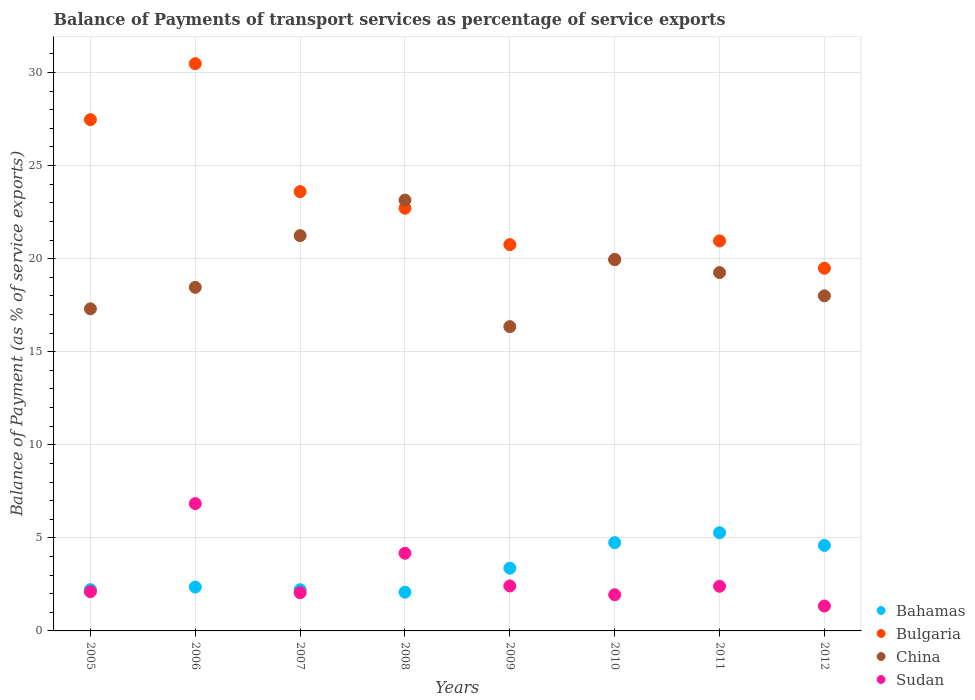Is the number of dotlines equal to the number of legend labels?
Make the answer very short. Yes. What is the balance of payments of transport services in China in 2012?
Give a very brief answer. 18. Across all years, what is the maximum balance of payments of transport services in China?
Your response must be concise. 23.14. Across all years, what is the minimum balance of payments of transport services in Sudan?
Ensure brevity in your answer.  1.34. In which year was the balance of payments of transport services in Sudan minimum?
Provide a short and direct response. 2012. What is the total balance of payments of transport services in Bulgaria in the graph?
Your response must be concise. 185.39. What is the difference between the balance of payments of transport services in Bulgaria in 2008 and that in 2011?
Provide a succinct answer. 1.75. What is the difference between the balance of payments of transport services in China in 2010 and the balance of payments of transport services in Bulgaria in 2007?
Provide a succinct answer. -3.65. What is the average balance of payments of transport services in Bahamas per year?
Keep it short and to the point. 3.36. In the year 2009, what is the difference between the balance of payments of transport services in Sudan and balance of payments of transport services in Bulgaria?
Offer a very short reply. -18.34. What is the ratio of the balance of payments of transport services in Bulgaria in 2006 to that in 2010?
Your answer should be very brief. 1.53. What is the difference between the highest and the second highest balance of payments of transport services in Bulgaria?
Offer a terse response. 3.01. What is the difference between the highest and the lowest balance of payments of transport services in Bulgaria?
Offer a terse response. 10.99. Is the balance of payments of transport services in Sudan strictly greater than the balance of payments of transport services in Bulgaria over the years?
Your answer should be compact. No. Does the graph contain grids?
Offer a very short reply. Yes. How many legend labels are there?
Your answer should be very brief. 4. What is the title of the graph?
Your response must be concise. Balance of Payments of transport services as percentage of service exports. Does "High income: OECD" appear as one of the legend labels in the graph?
Give a very brief answer. No. What is the label or title of the X-axis?
Offer a terse response. Years. What is the label or title of the Y-axis?
Give a very brief answer. Balance of Payment (as % of service exports). What is the Balance of Payment (as % of service exports) in Bahamas in 2005?
Ensure brevity in your answer.  2.22. What is the Balance of Payment (as % of service exports) of Bulgaria in 2005?
Give a very brief answer. 27.47. What is the Balance of Payment (as % of service exports) in China in 2005?
Give a very brief answer. 17.3. What is the Balance of Payment (as % of service exports) of Sudan in 2005?
Your response must be concise. 2.11. What is the Balance of Payment (as % of service exports) in Bahamas in 2006?
Ensure brevity in your answer.  2.36. What is the Balance of Payment (as % of service exports) in Bulgaria in 2006?
Make the answer very short. 30.47. What is the Balance of Payment (as % of service exports) of China in 2006?
Provide a short and direct response. 18.46. What is the Balance of Payment (as % of service exports) in Sudan in 2006?
Offer a terse response. 6.84. What is the Balance of Payment (as % of service exports) in Bahamas in 2007?
Your answer should be very brief. 2.21. What is the Balance of Payment (as % of service exports) of Bulgaria in 2007?
Make the answer very short. 23.6. What is the Balance of Payment (as % of service exports) in China in 2007?
Your answer should be very brief. 21.23. What is the Balance of Payment (as % of service exports) in Sudan in 2007?
Make the answer very short. 2.05. What is the Balance of Payment (as % of service exports) in Bahamas in 2008?
Ensure brevity in your answer.  2.08. What is the Balance of Payment (as % of service exports) in Bulgaria in 2008?
Ensure brevity in your answer.  22.71. What is the Balance of Payment (as % of service exports) of China in 2008?
Provide a succinct answer. 23.14. What is the Balance of Payment (as % of service exports) of Sudan in 2008?
Make the answer very short. 4.17. What is the Balance of Payment (as % of service exports) of Bahamas in 2009?
Ensure brevity in your answer.  3.37. What is the Balance of Payment (as % of service exports) of Bulgaria in 2009?
Provide a succinct answer. 20.75. What is the Balance of Payment (as % of service exports) of China in 2009?
Your answer should be compact. 16.35. What is the Balance of Payment (as % of service exports) of Sudan in 2009?
Make the answer very short. 2.41. What is the Balance of Payment (as % of service exports) in Bahamas in 2010?
Give a very brief answer. 4.74. What is the Balance of Payment (as % of service exports) in Bulgaria in 2010?
Provide a succinct answer. 19.95. What is the Balance of Payment (as % of service exports) in China in 2010?
Your response must be concise. 19.95. What is the Balance of Payment (as % of service exports) of Sudan in 2010?
Keep it short and to the point. 1.94. What is the Balance of Payment (as % of service exports) in Bahamas in 2011?
Offer a very short reply. 5.27. What is the Balance of Payment (as % of service exports) of Bulgaria in 2011?
Provide a succinct answer. 20.95. What is the Balance of Payment (as % of service exports) in China in 2011?
Your answer should be very brief. 19.25. What is the Balance of Payment (as % of service exports) of Sudan in 2011?
Ensure brevity in your answer.  2.4. What is the Balance of Payment (as % of service exports) of Bahamas in 2012?
Ensure brevity in your answer.  4.59. What is the Balance of Payment (as % of service exports) of Bulgaria in 2012?
Provide a short and direct response. 19.48. What is the Balance of Payment (as % of service exports) of China in 2012?
Provide a short and direct response. 18. What is the Balance of Payment (as % of service exports) in Sudan in 2012?
Your answer should be compact. 1.34. Across all years, what is the maximum Balance of Payment (as % of service exports) of Bahamas?
Provide a short and direct response. 5.27. Across all years, what is the maximum Balance of Payment (as % of service exports) of Bulgaria?
Offer a very short reply. 30.47. Across all years, what is the maximum Balance of Payment (as % of service exports) of China?
Keep it short and to the point. 23.14. Across all years, what is the maximum Balance of Payment (as % of service exports) of Sudan?
Offer a very short reply. 6.84. Across all years, what is the minimum Balance of Payment (as % of service exports) in Bahamas?
Keep it short and to the point. 2.08. Across all years, what is the minimum Balance of Payment (as % of service exports) of Bulgaria?
Give a very brief answer. 19.48. Across all years, what is the minimum Balance of Payment (as % of service exports) in China?
Provide a short and direct response. 16.35. Across all years, what is the minimum Balance of Payment (as % of service exports) in Sudan?
Make the answer very short. 1.34. What is the total Balance of Payment (as % of service exports) of Bahamas in the graph?
Your answer should be compact. 26.85. What is the total Balance of Payment (as % of service exports) of Bulgaria in the graph?
Provide a short and direct response. 185.39. What is the total Balance of Payment (as % of service exports) in China in the graph?
Provide a short and direct response. 153.69. What is the total Balance of Payment (as % of service exports) of Sudan in the graph?
Give a very brief answer. 23.27. What is the difference between the Balance of Payment (as % of service exports) of Bahamas in 2005 and that in 2006?
Provide a short and direct response. -0.14. What is the difference between the Balance of Payment (as % of service exports) of Bulgaria in 2005 and that in 2006?
Keep it short and to the point. -3.01. What is the difference between the Balance of Payment (as % of service exports) in China in 2005 and that in 2006?
Ensure brevity in your answer.  -1.15. What is the difference between the Balance of Payment (as % of service exports) in Sudan in 2005 and that in 2006?
Give a very brief answer. -4.73. What is the difference between the Balance of Payment (as % of service exports) of Bahamas in 2005 and that in 2007?
Offer a terse response. 0. What is the difference between the Balance of Payment (as % of service exports) in Bulgaria in 2005 and that in 2007?
Offer a terse response. 3.87. What is the difference between the Balance of Payment (as % of service exports) of China in 2005 and that in 2007?
Your response must be concise. -3.93. What is the difference between the Balance of Payment (as % of service exports) in Sudan in 2005 and that in 2007?
Provide a succinct answer. 0.05. What is the difference between the Balance of Payment (as % of service exports) in Bahamas in 2005 and that in 2008?
Your answer should be very brief. 0.14. What is the difference between the Balance of Payment (as % of service exports) in Bulgaria in 2005 and that in 2008?
Offer a terse response. 4.76. What is the difference between the Balance of Payment (as % of service exports) in China in 2005 and that in 2008?
Give a very brief answer. -5.84. What is the difference between the Balance of Payment (as % of service exports) of Sudan in 2005 and that in 2008?
Provide a succinct answer. -2.07. What is the difference between the Balance of Payment (as % of service exports) in Bahamas in 2005 and that in 2009?
Give a very brief answer. -1.15. What is the difference between the Balance of Payment (as % of service exports) in Bulgaria in 2005 and that in 2009?
Provide a succinct answer. 6.71. What is the difference between the Balance of Payment (as % of service exports) in China in 2005 and that in 2009?
Offer a terse response. 0.96. What is the difference between the Balance of Payment (as % of service exports) in Sudan in 2005 and that in 2009?
Keep it short and to the point. -0.31. What is the difference between the Balance of Payment (as % of service exports) in Bahamas in 2005 and that in 2010?
Offer a terse response. -2.53. What is the difference between the Balance of Payment (as % of service exports) of Bulgaria in 2005 and that in 2010?
Make the answer very short. 7.52. What is the difference between the Balance of Payment (as % of service exports) in China in 2005 and that in 2010?
Ensure brevity in your answer.  -2.65. What is the difference between the Balance of Payment (as % of service exports) in Sudan in 2005 and that in 2010?
Keep it short and to the point. 0.16. What is the difference between the Balance of Payment (as % of service exports) in Bahamas in 2005 and that in 2011?
Provide a short and direct response. -3.06. What is the difference between the Balance of Payment (as % of service exports) of Bulgaria in 2005 and that in 2011?
Your response must be concise. 6.51. What is the difference between the Balance of Payment (as % of service exports) in China in 2005 and that in 2011?
Offer a very short reply. -1.95. What is the difference between the Balance of Payment (as % of service exports) of Sudan in 2005 and that in 2011?
Ensure brevity in your answer.  -0.29. What is the difference between the Balance of Payment (as % of service exports) in Bahamas in 2005 and that in 2012?
Provide a short and direct response. -2.38. What is the difference between the Balance of Payment (as % of service exports) of Bulgaria in 2005 and that in 2012?
Your answer should be compact. 7.98. What is the difference between the Balance of Payment (as % of service exports) of China in 2005 and that in 2012?
Give a very brief answer. -0.7. What is the difference between the Balance of Payment (as % of service exports) in Sudan in 2005 and that in 2012?
Provide a short and direct response. 0.77. What is the difference between the Balance of Payment (as % of service exports) of Bahamas in 2006 and that in 2007?
Provide a short and direct response. 0.14. What is the difference between the Balance of Payment (as % of service exports) of Bulgaria in 2006 and that in 2007?
Ensure brevity in your answer.  6.87. What is the difference between the Balance of Payment (as % of service exports) of China in 2006 and that in 2007?
Your response must be concise. -2.78. What is the difference between the Balance of Payment (as % of service exports) in Sudan in 2006 and that in 2007?
Offer a very short reply. 4.79. What is the difference between the Balance of Payment (as % of service exports) of Bahamas in 2006 and that in 2008?
Give a very brief answer. 0.28. What is the difference between the Balance of Payment (as % of service exports) in Bulgaria in 2006 and that in 2008?
Ensure brevity in your answer.  7.77. What is the difference between the Balance of Payment (as % of service exports) in China in 2006 and that in 2008?
Your answer should be very brief. -4.69. What is the difference between the Balance of Payment (as % of service exports) of Sudan in 2006 and that in 2008?
Make the answer very short. 2.67. What is the difference between the Balance of Payment (as % of service exports) in Bahamas in 2006 and that in 2009?
Your answer should be compact. -1.01. What is the difference between the Balance of Payment (as % of service exports) in Bulgaria in 2006 and that in 2009?
Offer a terse response. 9.72. What is the difference between the Balance of Payment (as % of service exports) in China in 2006 and that in 2009?
Offer a very short reply. 2.11. What is the difference between the Balance of Payment (as % of service exports) in Sudan in 2006 and that in 2009?
Provide a short and direct response. 4.43. What is the difference between the Balance of Payment (as % of service exports) of Bahamas in 2006 and that in 2010?
Your response must be concise. -2.38. What is the difference between the Balance of Payment (as % of service exports) in Bulgaria in 2006 and that in 2010?
Your answer should be very brief. 10.52. What is the difference between the Balance of Payment (as % of service exports) of China in 2006 and that in 2010?
Offer a very short reply. -1.49. What is the difference between the Balance of Payment (as % of service exports) in Sudan in 2006 and that in 2010?
Your response must be concise. 4.9. What is the difference between the Balance of Payment (as % of service exports) of Bahamas in 2006 and that in 2011?
Provide a short and direct response. -2.92. What is the difference between the Balance of Payment (as % of service exports) of Bulgaria in 2006 and that in 2011?
Give a very brief answer. 9.52. What is the difference between the Balance of Payment (as % of service exports) in China in 2006 and that in 2011?
Your response must be concise. -0.79. What is the difference between the Balance of Payment (as % of service exports) in Sudan in 2006 and that in 2011?
Provide a succinct answer. 4.44. What is the difference between the Balance of Payment (as % of service exports) in Bahamas in 2006 and that in 2012?
Make the answer very short. -2.24. What is the difference between the Balance of Payment (as % of service exports) in Bulgaria in 2006 and that in 2012?
Offer a terse response. 10.99. What is the difference between the Balance of Payment (as % of service exports) in China in 2006 and that in 2012?
Give a very brief answer. 0.46. What is the difference between the Balance of Payment (as % of service exports) of Sudan in 2006 and that in 2012?
Your response must be concise. 5.5. What is the difference between the Balance of Payment (as % of service exports) in Bahamas in 2007 and that in 2008?
Your answer should be compact. 0.13. What is the difference between the Balance of Payment (as % of service exports) of Bulgaria in 2007 and that in 2008?
Your answer should be very brief. 0.89. What is the difference between the Balance of Payment (as % of service exports) in China in 2007 and that in 2008?
Make the answer very short. -1.91. What is the difference between the Balance of Payment (as % of service exports) of Sudan in 2007 and that in 2008?
Your response must be concise. -2.12. What is the difference between the Balance of Payment (as % of service exports) in Bahamas in 2007 and that in 2009?
Offer a terse response. -1.16. What is the difference between the Balance of Payment (as % of service exports) in Bulgaria in 2007 and that in 2009?
Your answer should be very brief. 2.85. What is the difference between the Balance of Payment (as % of service exports) in China in 2007 and that in 2009?
Offer a terse response. 4.89. What is the difference between the Balance of Payment (as % of service exports) in Sudan in 2007 and that in 2009?
Provide a short and direct response. -0.36. What is the difference between the Balance of Payment (as % of service exports) of Bahamas in 2007 and that in 2010?
Provide a succinct answer. -2.53. What is the difference between the Balance of Payment (as % of service exports) of Bulgaria in 2007 and that in 2010?
Make the answer very short. 3.65. What is the difference between the Balance of Payment (as % of service exports) in China in 2007 and that in 2010?
Your answer should be very brief. 1.29. What is the difference between the Balance of Payment (as % of service exports) of Sudan in 2007 and that in 2010?
Offer a very short reply. 0.11. What is the difference between the Balance of Payment (as % of service exports) of Bahamas in 2007 and that in 2011?
Provide a short and direct response. -3.06. What is the difference between the Balance of Payment (as % of service exports) of Bulgaria in 2007 and that in 2011?
Offer a terse response. 2.65. What is the difference between the Balance of Payment (as % of service exports) in China in 2007 and that in 2011?
Offer a terse response. 1.98. What is the difference between the Balance of Payment (as % of service exports) in Sudan in 2007 and that in 2011?
Your response must be concise. -0.35. What is the difference between the Balance of Payment (as % of service exports) of Bahamas in 2007 and that in 2012?
Provide a short and direct response. -2.38. What is the difference between the Balance of Payment (as % of service exports) in Bulgaria in 2007 and that in 2012?
Provide a succinct answer. 4.12. What is the difference between the Balance of Payment (as % of service exports) in China in 2007 and that in 2012?
Offer a terse response. 3.23. What is the difference between the Balance of Payment (as % of service exports) of Sudan in 2007 and that in 2012?
Provide a succinct answer. 0.71. What is the difference between the Balance of Payment (as % of service exports) of Bahamas in 2008 and that in 2009?
Your answer should be very brief. -1.29. What is the difference between the Balance of Payment (as % of service exports) in Bulgaria in 2008 and that in 2009?
Make the answer very short. 1.96. What is the difference between the Balance of Payment (as % of service exports) of China in 2008 and that in 2009?
Make the answer very short. 6.8. What is the difference between the Balance of Payment (as % of service exports) of Sudan in 2008 and that in 2009?
Ensure brevity in your answer.  1.76. What is the difference between the Balance of Payment (as % of service exports) of Bahamas in 2008 and that in 2010?
Your response must be concise. -2.66. What is the difference between the Balance of Payment (as % of service exports) of Bulgaria in 2008 and that in 2010?
Make the answer very short. 2.76. What is the difference between the Balance of Payment (as % of service exports) in China in 2008 and that in 2010?
Your answer should be compact. 3.2. What is the difference between the Balance of Payment (as % of service exports) in Sudan in 2008 and that in 2010?
Your answer should be compact. 2.23. What is the difference between the Balance of Payment (as % of service exports) of Bahamas in 2008 and that in 2011?
Make the answer very short. -3.19. What is the difference between the Balance of Payment (as % of service exports) of Bulgaria in 2008 and that in 2011?
Ensure brevity in your answer.  1.75. What is the difference between the Balance of Payment (as % of service exports) of China in 2008 and that in 2011?
Make the answer very short. 3.89. What is the difference between the Balance of Payment (as % of service exports) of Sudan in 2008 and that in 2011?
Your response must be concise. 1.77. What is the difference between the Balance of Payment (as % of service exports) of Bahamas in 2008 and that in 2012?
Ensure brevity in your answer.  -2.51. What is the difference between the Balance of Payment (as % of service exports) in Bulgaria in 2008 and that in 2012?
Your response must be concise. 3.22. What is the difference between the Balance of Payment (as % of service exports) in China in 2008 and that in 2012?
Your answer should be compact. 5.14. What is the difference between the Balance of Payment (as % of service exports) in Sudan in 2008 and that in 2012?
Offer a very short reply. 2.83. What is the difference between the Balance of Payment (as % of service exports) in Bahamas in 2009 and that in 2010?
Offer a terse response. -1.37. What is the difference between the Balance of Payment (as % of service exports) of Bulgaria in 2009 and that in 2010?
Provide a short and direct response. 0.8. What is the difference between the Balance of Payment (as % of service exports) of China in 2009 and that in 2010?
Provide a succinct answer. -3.6. What is the difference between the Balance of Payment (as % of service exports) of Sudan in 2009 and that in 2010?
Your answer should be very brief. 0.47. What is the difference between the Balance of Payment (as % of service exports) in Bahamas in 2009 and that in 2011?
Make the answer very short. -1.9. What is the difference between the Balance of Payment (as % of service exports) of Bulgaria in 2009 and that in 2011?
Your answer should be compact. -0.2. What is the difference between the Balance of Payment (as % of service exports) in China in 2009 and that in 2011?
Your answer should be very brief. -2.91. What is the difference between the Balance of Payment (as % of service exports) of Sudan in 2009 and that in 2011?
Give a very brief answer. 0.02. What is the difference between the Balance of Payment (as % of service exports) of Bahamas in 2009 and that in 2012?
Your answer should be very brief. -1.22. What is the difference between the Balance of Payment (as % of service exports) in Bulgaria in 2009 and that in 2012?
Your answer should be compact. 1.27. What is the difference between the Balance of Payment (as % of service exports) in China in 2009 and that in 2012?
Ensure brevity in your answer.  -1.66. What is the difference between the Balance of Payment (as % of service exports) of Sudan in 2009 and that in 2012?
Offer a terse response. 1.08. What is the difference between the Balance of Payment (as % of service exports) of Bahamas in 2010 and that in 2011?
Offer a very short reply. -0.53. What is the difference between the Balance of Payment (as % of service exports) in Bulgaria in 2010 and that in 2011?
Offer a very short reply. -1. What is the difference between the Balance of Payment (as % of service exports) in China in 2010 and that in 2011?
Your answer should be compact. 0.7. What is the difference between the Balance of Payment (as % of service exports) of Sudan in 2010 and that in 2011?
Ensure brevity in your answer.  -0.46. What is the difference between the Balance of Payment (as % of service exports) of Bahamas in 2010 and that in 2012?
Provide a succinct answer. 0.15. What is the difference between the Balance of Payment (as % of service exports) of Bulgaria in 2010 and that in 2012?
Offer a terse response. 0.47. What is the difference between the Balance of Payment (as % of service exports) of China in 2010 and that in 2012?
Provide a succinct answer. 1.95. What is the difference between the Balance of Payment (as % of service exports) of Sudan in 2010 and that in 2012?
Make the answer very short. 0.61. What is the difference between the Balance of Payment (as % of service exports) in Bahamas in 2011 and that in 2012?
Offer a terse response. 0.68. What is the difference between the Balance of Payment (as % of service exports) of Bulgaria in 2011 and that in 2012?
Ensure brevity in your answer.  1.47. What is the difference between the Balance of Payment (as % of service exports) in China in 2011 and that in 2012?
Provide a short and direct response. 1.25. What is the difference between the Balance of Payment (as % of service exports) of Sudan in 2011 and that in 2012?
Provide a succinct answer. 1.06. What is the difference between the Balance of Payment (as % of service exports) in Bahamas in 2005 and the Balance of Payment (as % of service exports) in Bulgaria in 2006?
Your answer should be compact. -28.26. What is the difference between the Balance of Payment (as % of service exports) in Bahamas in 2005 and the Balance of Payment (as % of service exports) in China in 2006?
Your answer should be compact. -16.24. What is the difference between the Balance of Payment (as % of service exports) of Bahamas in 2005 and the Balance of Payment (as % of service exports) of Sudan in 2006?
Offer a terse response. -4.62. What is the difference between the Balance of Payment (as % of service exports) of Bulgaria in 2005 and the Balance of Payment (as % of service exports) of China in 2006?
Your response must be concise. 9.01. What is the difference between the Balance of Payment (as % of service exports) in Bulgaria in 2005 and the Balance of Payment (as % of service exports) in Sudan in 2006?
Keep it short and to the point. 20.63. What is the difference between the Balance of Payment (as % of service exports) in China in 2005 and the Balance of Payment (as % of service exports) in Sudan in 2006?
Provide a succinct answer. 10.46. What is the difference between the Balance of Payment (as % of service exports) of Bahamas in 2005 and the Balance of Payment (as % of service exports) of Bulgaria in 2007?
Your response must be concise. -21.38. What is the difference between the Balance of Payment (as % of service exports) of Bahamas in 2005 and the Balance of Payment (as % of service exports) of China in 2007?
Your answer should be compact. -19.02. What is the difference between the Balance of Payment (as % of service exports) in Bahamas in 2005 and the Balance of Payment (as % of service exports) in Sudan in 2007?
Your answer should be compact. 0.16. What is the difference between the Balance of Payment (as % of service exports) of Bulgaria in 2005 and the Balance of Payment (as % of service exports) of China in 2007?
Keep it short and to the point. 6.23. What is the difference between the Balance of Payment (as % of service exports) of Bulgaria in 2005 and the Balance of Payment (as % of service exports) of Sudan in 2007?
Provide a short and direct response. 25.41. What is the difference between the Balance of Payment (as % of service exports) in China in 2005 and the Balance of Payment (as % of service exports) in Sudan in 2007?
Ensure brevity in your answer.  15.25. What is the difference between the Balance of Payment (as % of service exports) of Bahamas in 2005 and the Balance of Payment (as % of service exports) of Bulgaria in 2008?
Offer a very short reply. -20.49. What is the difference between the Balance of Payment (as % of service exports) of Bahamas in 2005 and the Balance of Payment (as % of service exports) of China in 2008?
Offer a very short reply. -20.93. What is the difference between the Balance of Payment (as % of service exports) in Bahamas in 2005 and the Balance of Payment (as % of service exports) in Sudan in 2008?
Offer a terse response. -1.96. What is the difference between the Balance of Payment (as % of service exports) of Bulgaria in 2005 and the Balance of Payment (as % of service exports) of China in 2008?
Provide a succinct answer. 4.32. What is the difference between the Balance of Payment (as % of service exports) in Bulgaria in 2005 and the Balance of Payment (as % of service exports) in Sudan in 2008?
Make the answer very short. 23.29. What is the difference between the Balance of Payment (as % of service exports) of China in 2005 and the Balance of Payment (as % of service exports) of Sudan in 2008?
Keep it short and to the point. 13.13. What is the difference between the Balance of Payment (as % of service exports) of Bahamas in 2005 and the Balance of Payment (as % of service exports) of Bulgaria in 2009?
Your answer should be compact. -18.54. What is the difference between the Balance of Payment (as % of service exports) in Bahamas in 2005 and the Balance of Payment (as % of service exports) in China in 2009?
Make the answer very short. -14.13. What is the difference between the Balance of Payment (as % of service exports) of Bahamas in 2005 and the Balance of Payment (as % of service exports) of Sudan in 2009?
Give a very brief answer. -0.2. What is the difference between the Balance of Payment (as % of service exports) of Bulgaria in 2005 and the Balance of Payment (as % of service exports) of China in 2009?
Keep it short and to the point. 11.12. What is the difference between the Balance of Payment (as % of service exports) of Bulgaria in 2005 and the Balance of Payment (as % of service exports) of Sudan in 2009?
Your response must be concise. 25.05. What is the difference between the Balance of Payment (as % of service exports) of China in 2005 and the Balance of Payment (as % of service exports) of Sudan in 2009?
Offer a terse response. 14.89. What is the difference between the Balance of Payment (as % of service exports) in Bahamas in 2005 and the Balance of Payment (as % of service exports) in Bulgaria in 2010?
Offer a terse response. -17.74. What is the difference between the Balance of Payment (as % of service exports) of Bahamas in 2005 and the Balance of Payment (as % of service exports) of China in 2010?
Keep it short and to the point. -17.73. What is the difference between the Balance of Payment (as % of service exports) of Bahamas in 2005 and the Balance of Payment (as % of service exports) of Sudan in 2010?
Make the answer very short. 0.27. What is the difference between the Balance of Payment (as % of service exports) of Bulgaria in 2005 and the Balance of Payment (as % of service exports) of China in 2010?
Offer a very short reply. 7.52. What is the difference between the Balance of Payment (as % of service exports) in Bulgaria in 2005 and the Balance of Payment (as % of service exports) in Sudan in 2010?
Ensure brevity in your answer.  25.52. What is the difference between the Balance of Payment (as % of service exports) of China in 2005 and the Balance of Payment (as % of service exports) of Sudan in 2010?
Your answer should be very brief. 15.36. What is the difference between the Balance of Payment (as % of service exports) of Bahamas in 2005 and the Balance of Payment (as % of service exports) of Bulgaria in 2011?
Your response must be concise. -18.74. What is the difference between the Balance of Payment (as % of service exports) in Bahamas in 2005 and the Balance of Payment (as % of service exports) in China in 2011?
Give a very brief answer. -17.04. What is the difference between the Balance of Payment (as % of service exports) of Bahamas in 2005 and the Balance of Payment (as % of service exports) of Sudan in 2011?
Give a very brief answer. -0.18. What is the difference between the Balance of Payment (as % of service exports) in Bulgaria in 2005 and the Balance of Payment (as % of service exports) in China in 2011?
Give a very brief answer. 8.21. What is the difference between the Balance of Payment (as % of service exports) of Bulgaria in 2005 and the Balance of Payment (as % of service exports) of Sudan in 2011?
Your response must be concise. 25.07. What is the difference between the Balance of Payment (as % of service exports) of China in 2005 and the Balance of Payment (as % of service exports) of Sudan in 2011?
Ensure brevity in your answer.  14.9. What is the difference between the Balance of Payment (as % of service exports) of Bahamas in 2005 and the Balance of Payment (as % of service exports) of Bulgaria in 2012?
Keep it short and to the point. -17.27. What is the difference between the Balance of Payment (as % of service exports) of Bahamas in 2005 and the Balance of Payment (as % of service exports) of China in 2012?
Your response must be concise. -15.79. What is the difference between the Balance of Payment (as % of service exports) in Bahamas in 2005 and the Balance of Payment (as % of service exports) in Sudan in 2012?
Your answer should be very brief. 0.88. What is the difference between the Balance of Payment (as % of service exports) of Bulgaria in 2005 and the Balance of Payment (as % of service exports) of China in 2012?
Your answer should be very brief. 9.46. What is the difference between the Balance of Payment (as % of service exports) in Bulgaria in 2005 and the Balance of Payment (as % of service exports) in Sudan in 2012?
Make the answer very short. 26.13. What is the difference between the Balance of Payment (as % of service exports) of China in 2005 and the Balance of Payment (as % of service exports) of Sudan in 2012?
Offer a terse response. 15.97. What is the difference between the Balance of Payment (as % of service exports) in Bahamas in 2006 and the Balance of Payment (as % of service exports) in Bulgaria in 2007?
Your answer should be compact. -21.24. What is the difference between the Balance of Payment (as % of service exports) in Bahamas in 2006 and the Balance of Payment (as % of service exports) in China in 2007?
Give a very brief answer. -18.88. What is the difference between the Balance of Payment (as % of service exports) in Bahamas in 2006 and the Balance of Payment (as % of service exports) in Sudan in 2007?
Give a very brief answer. 0.3. What is the difference between the Balance of Payment (as % of service exports) of Bulgaria in 2006 and the Balance of Payment (as % of service exports) of China in 2007?
Your answer should be very brief. 9.24. What is the difference between the Balance of Payment (as % of service exports) of Bulgaria in 2006 and the Balance of Payment (as % of service exports) of Sudan in 2007?
Ensure brevity in your answer.  28.42. What is the difference between the Balance of Payment (as % of service exports) of China in 2006 and the Balance of Payment (as % of service exports) of Sudan in 2007?
Provide a succinct answer. 16.41. What is the difference between the Balance of Payment (as % of service exports) in Bahamas in 2006 and the Balance of Payment (as % of service exports) in Bulgaria in 2008?
Ensure brevity in your answer.  -20.35. What is the difference between the Balance of Payment (as % of service exports) of Bahamas in 2006 and the Balance of Payment (as % of service exports) of China in 2008?
Offer a terse response. -20.79. What is the difference between the Balance of Payment (as % of service exports) of Bahamas in 2006 and the Balance of Payment (as % of service exports) of Sudan in 2008?
Your answer should be compact. -1.82. What is the difference between the Balance of Payment (as % of service exports) in Bulgaria in 2006 and the Balance of Payment (as % of service exports) in China in 2008?
Your answer should be compact. 7.33. What is the difference between the Balance of Payment (as % of service exports) in Bulgaria in 2006 and the Balance of Payment (as % of service exports) in Sudan in 2008?
Provide a short and direct response. 26.3. What is the difference between the Balance of Payment (as % of service exports) in China in 2006 and the Balance of Payment (as % of service exports) in Sudan in 2008?
Ensure brevity in your answer.  14.29. What is the difference between the Balance of Payment (as % of service exports) in Bahamas in 2006 and the Balance of Payment (as % of service exports) in Bulgaria in 2009?
Make the answer very short. -18.4. What is the difference between the Balance of Payment (as % of service exports) in Bahamas in 2006 and the Balance of Payment (as % of service exports) in China in 2009?
Offer a very short reply. -13.99. What is the difference between the Balance of Payment (as % of service exports) of Bahamas in 2006 and the Balance of Payment (as % of service exports) of Sudan in 2009?
Ensure brevity in your answer.  -0.06. What is the difference between the Balance of Payment (as % of service exports) of Bulgaria in 2006 and the Balance of Payment (as % of service exports) of China in 2009?
Provide a succinct answer. 14.13. What is the difference between the Balance of Payment (as % of service exports) of Bulgaria in 2006 and the Balance of Payment (as % of service exports) of Sudan in 2009?
Provide a short and direct response. 28.06. What is the difference between the Balance of Payment (as % of service exports) of China in 2006 and the Balance of Payment (as % of service exports) of Sudan in 2009?
Make the answer very short. 16.04. What is the difference between the Balance of Payment (as % of service exports) of Bahamas in 2006 and the Balance of Payment (as % of service exports) of Bulgaria in 2010?
Your response must be concise. -17.59. What is the difference between the Balance of Payment (as % of service exports) of Bahamas in 2006 and the Balance of Payment (as % of service exports) of China in 2010?
Give a very brief answer. -17.59. What is the difference between the Balance of Payment (as % of service exports) of Bahamas in 2006 and the Balance of Payment (as % of service exports) of Sudan in 2010?
Provide a succinct answer. 0.41. What is the difference between the Balance of Payment (as % of service exports) of Bulgaria in 2006 and the Balance of Payment (as % of service exports) of China in 2010?
Give a very brief answer. 10.52. What is the difference between the Balance of Payment (as % of service exports) of Bulgaria in 2006 and the Balance of Payment (as % of service exports) of Sudan in 2010?
Provide a short and direct response. 28.53. What is the difference between the Balance of Payment (as % of service exports) of China in 2006 and the Balance of Payment (as % of service exports) of Sudan in 2010?
Offer a terse response. 16.52. What is the difference between the Balance of Payment (as % of service exports) of Bahamas in 2006 and the Balance of Payment (as % of service exports) of Bulgaria in 2011?
Give a very brief answer. -18.6. What is the difference between the Balance of Payment (as % of service exports) of Bahamas in 2006 and the Balance of Payment (as % of service exports) of China in 2011?
Your response must be concise. -16.89. What is the difference between the Balance of Payment (as % of service exports) in Bahamas in 2006 and the Balance of Payment (as % of service exports) in Sudan in 2011?
Your response must be concise. -0.04. What is the difference between the Balance of Payment (as % of service exports) of Bulgaria in 2006 and the Balance of Payment (as % of service exports) of China in 2011?
Provide a short and direct response. 11.22. What is the difference between the Balance of Payment (as % of service exports) in Bulgaria in 2006 and the Balance of Payment (as % of service exports) in Sudan in 2011?
Offer a very short reply. 28.07. What is the difference between the Balance of Payment (as % of service exports) in China in 2006 and the Balance of Payment (as % of service exports) in Sudan in 2011?
Provide a succinct answer. 16.06. What is the difference between the Balance of Payment (as % of service exports) of Bahamas in 2006 and the Balance of Payment (as % of service exports) of Bulgaria in 2012?
Give a very brief answer. -17.13. What is the difference between the Balance of Payment (as % of service exports) of Bahamas in 2006 and the Balance of Payment (as % of service exports) of China in 2012?
Keep it short and to the point. -15.65. What is the difference between the Balance of Payment (as % of service exports) of Bahamas in 2006 and the Balance of Payment (as % of service exports) of Sudan in 2012?
Provide a succinct answer. 1.02. What is the difference between the Balance of Payment (as % of service exports) of Bulgaria in 2006 and the Balance of Payment (as % of service exports) of China in 2012?
Offer a terse response. 12.47. What is the difference between the Balance of Payment (as % of service exports) in Bulgaria in 2006 and the Balance of Payment (as % of service exports) in Sudan in 2012?
Ensure brevity in your answer.  29.13. What is the difference between the Balance of Payment (as % of service exports) in China in 2006 and the Balance of Payment (as % of service exports) in Sudan in 2012?
Your answer should be very brief. 17.12. What is the difference between the Balance of Payment (as % of service exports) in Bahamas in 2007 and the Balance of Payment (as % of service exports) in Bulgaria in 2008?
Make the answer very short. -20.49. What is the difference between the Balance of Payment (as % of service exports) of Bahamas in 2007 and the Balance of Payment (as % of service exports) of China in 2008?
Your answer should be compact. -20.93. What is the difference between the Balance of Payment (as % of service exports) in Bahamas in 2007 and the Balance of Payment (as % of service exports) in Sudan in 2008?
Offer a very short reply. -1.96. What is the difference between the Balance of Payment (as % of service exports) in Bulgaria in 2007 and the Balance of Payment (as % of service exports) in China in 2008?
Your answer should be compact. 0.45. What is the difference between the Balance of Payment (as % of service exports) of Bulgaria in 2007 and the Balance of Payment (as % of service exports) of Sudan in 2008?
Ensure brevity in your answer.  19.43. What is the difference between the Balance of Payment (as % of service exports) in China in 2007 and the Balance of Payment (as % of service exports) in Sudan in 2008?
Your answer should be very brief. 17.06. What is the difference between the Balance of Payment (as % of service exports) of Bahamas in 2007 and the Balance of Payment (as % of service exports) of Bulgaria in 2009?
Your answer should be compact. -18.54. What is the difference between the Balance of Payment (as % of service exports) in Bahamas in 2007 and the Balance of Payment (as % of service exports) in China in 2009?
Give a very brief answer. -14.13. What is the difference between the Balance of Payment (as % of service exports) of Bahamas in 2007 and the Balance of Payment (as % of service exports) of Sudan in 2009?
Provide a short and direct response. -0.2. What is the difference between the Balance of Payment (as % of service exports) in Bulgaria in 2007 and the Balance of Payment (as % of service exports) in China in 2009?
Provide a succinct answer. 7.25. What is the difference between the Balance of Payment (as % of service exports) of Bulgaria in 2007 and the Balance of Payment (as % of service exports) of Sudan in 2009?
Your response must be concise. 21.18. What is the difference between the Balance of Payment (as % of service exports) of China in 2007 and the Balance of Payment (as % of service exports) of Sudan in 2009?
Offer a very short reply. 18.82. What is the difference between the Balance of Payment (as % of service exports) of Bahamas in 2007 and the Balance of Payment (as % of service exports) of Bulgaria in 2010?
Make the answer very short. -17.74. What is the difference between the Balance of Payment (as % of service exports) of Bahamas in 2007 and the Balance of Payment (as % of service exports) of China in 2010?
Keep it short and to the point. -17.74. What is the difference between the Balance of Payment (as % of service exports) of Bahamas in 2007 and the Balance of Payment (as % of service exports) of Sudan in 2010?
Give a very brief answer. 0.27. What is the difference between the Balance of Payment (as % of service exports) in Bulgaria in 2007 and the Balance of Payment (as % of service exports) in China in 2010?
Offer a very short reply. 3.65. What is the difference between the Balance of Payment (as % of service exports) of Bulgaria in 2007 and the Balance of Payment (as % of service exports) of Sudan in 2010?
Your answer should be compact. 21.66. What is the difference between the Balance of Payment (as % of service exports) of China in 2007 and the Balance of Payment (as % of service exports) of Sudan in 2010?
Your response must be concise. 19.29. What is the difference between the Balance of Payment (as % of service exports) in Bahamas in 2007 and the Balance of Payment (as % of service exports) in Bulgaria in 2011?
Provide a succinct answer. -18.74. What is the difference between the Balance of Payment (as % of service exports) of Bahamas in 2007 and the Balance of Payment (as % of service exports) of China in 2011?
Ensure brevity in your answer.  -17.04. What is the difference between the Balance of Payment (as % of service exports) of Bahamas in 2007 and the Balance of Payment (as % of service exports) of Sudan in 2011?
Your response must be concise. -0.19. What is the difference between the Balance of Payment (as % of service exports) in Bulgaria in 2007 and the Balance of Payment (as % of service exports) in China in 2011?
Ensure brevity in your answer.  4.35. What is the difference between the Balance of Payment (as % of service exports) of Bulgaria in 2007 and the Balance of Payment (as % of service exports) of Sudan in 2011?
Offer a very short reply. 21.2. What is the difference between the Balance of Payment (as % of service exports) in China in 2007 and the Balance of Payment (as % of service exports) in Sudan in 2011?
Your answer should be compact. 18.84. What is the difference between the Balance of Payment (as % of service exports) in Bahamas in 2007 and the Balance of Payment (as % of service exports) in Bulgaria in 2012?
Your answer should be compact. -17.27. What is the difference between the Balance of Payment (as % of service exports) of Bahamas in 2007 and the Balance of Payment (as % of service exports) of China in 2012?
Offer a very short reply. -15.79. What is the difference between the Balance of Payment (as % of service exports) in Bahamas in 2007 and the Balance of Payment (as % of service exports) in Sudan in 2012?
Provide a short and direct response. 0.88. What is the difference between the Balance of Payment (as % of service exports) in Bulgaria in 2007 and the Balance of Payment (as % of service exports) in China in 2012?
Ensure brevity in your answer.  5.6. What is the difference between the Balance of Payment (as % of service exports) in Bulgaria in 2007 and the Balance of Payment (as % of service exports) in Sudan in 2012?
Ensure brevity in your answer.  22.26. What is the difference between the Balance of Payment (as % of service exports) in China in 2007 and the Balance of Payment (as % of service exports) in Sudan in 2012?
Provide a succinct answer. 19.9. What is the difference between the Balance of Payment (as % of service exports) of Bahamas in 2008 and the Balance of Payment (as % of service exports) of Bulgaria in 2009?
Your answer should be very brief. -18.67. What is the difference between the Balance of Payment (as % of service exports) of Bahamas in 2008 and the Balance of Payment (as % of service exports) of China in 2009?
Your answer should be compact. -14.27. What is the difference between the Balance of Payment (as % of service exports) in Bahamas in 2008 and the Balance of Payment (as % of service exports) in Sudan in 2009?
Ensure brevity in your answer.  -0.33. What is the difference between the Balance of Payment (as % of service exports) of Bulgaria in 2008 and the Balance of Payment (as % of service exports) of China in 2009?
Give a very brief answer. 6.36. What is the difference between the Balance of Payment (as % of service exports) of Bulgaria in 2008 and the Balance of Payment (as % of service exports) of Sudan in 2009?
Your answer should be very brief. 20.29. What is the difference between the Balance of Payment (as % of service exports) in China in 2008 and the Balance of Payment (as % of service exports) in Sudan in 2009?
Your answer should be compact. 20.73. What is the difference between the Balance of Payment (as % of service exports) in Bahamas in 2008 and the Balance of Payment (as % of service exports) in Bulgaria in 2010?
Offer a very short reply. -17.87. What is the difference between the Balance of Payment (as % of service exports) of Bahamas in 2008 and the Balance of Payment (as % of service exports) of China in 2010?
Provide a succinct answer. -17.87. What is the difference between the Balance of Payment (as % of service exports) in Bahamas in 2008 and the Balance of Payment (as % of service exports) in Sudan in 2010?
Your answer should be compact. 0.14. What is the difference between the Balance of Payment (as % of service exports) in Bulgaria in 2008 and the Balance of Payment (as % of service exports) in China in 2010?
Keep it short and to the point. 2.76. What is the difference between the Balance of Payment (as % of service exports) of Bulgaria in 2008 and the Balance of Payment (as % of service exports) of Sudan in 2010?
Provide a short and direct response. 20.76. What is the difference between the Balance of Payment (as % of service exports) of China in 2008 and the Balance of Payment (as % of service exports) of Sudan in 2010?
Offer a very short reply. 21.2. What is the difference between the Balance of Payment (as % of service exports) of Bahamas in 2008 and the Balance of Payment (as % of service exports) of Bulgaria in 2011?
Your answer should be very brief. -18.87. What is the difference between the Balance of Payment (as % of service exports) of Bahamas in 2008 and the Balance of Payment (as % of service exports) of China in 2011?
Keep it short and to the point. -17.17. What is the difference between the Balance of Payment (as % of service exports) in Bahamas in 2008 and the Balance of Payment (as % of service exports) in Sudan in 2011?
Provide a short and direct response. -0.32. What is the difference between the Balance of Payment (as % of service exports) of Bulgaria in 2008 and the Balance of Payment (as % of service exports) of China in 2011?
Your answer should be very brief. 3.46. What is the difference between the Balance of Payment (as % of service exports) of Bulgaria in 2008 and the Balance of Payment (as % of service exports) of Sudan in 2011?
Your answer should be very brief. 20.31. What is the difference between the Balance of Payment (as % of service exports) of China in 2008 and the Balance of Payment (as % of service exports) of Sudan in 2011?
Keep it short and to the point. 20.75. What is the difference between the Balance of Payment (as % of service exports) of Bahamas in 2008 and the Balance of Payment (as % of service exports) of Bulgaria in 2012?
Give a very brief answer. -17.4. What is the difference between the Balance of Payment (as % of service exports) of Bahamas in 2008 and the Balance of Payment (as % of service exports) of China in 2012?
Keep it short and to the point. -15.92. What is the difference between the Balance of Payment (as % of service exports) in Bahamas in 2008 and the Balance of Payment (as % of service exports) in Sudan in 2012?
Offer a very short reply. 0.74. What is the difference between the Balance of Payment (as % of service exports) of Bulgaria in 2008 and the Balance of Payment (as % of service exports) of China in 2012?
Your answer should be compact. 4.71. What is the difference between the Balance of Payment (as % of service exports) of Bulgaria in 2008 and the Balance of Payment (as % of service exports) of Sudan in 2012?
Offer a very short reply. 21.37. What is the difference between the Balance of Payment (as % of service exports) in China in 2008 and the Balance of Payment (as % of service exports) in Sudan in 2012?
Your response must be concise. 21.81. What is the difference between the Balance of Payment (as % of service exports) in Bahamas in 2009 and the Balance of Payment (as % of service exports) in Bulgaria in 2010?
Make the answer very short. -16.58. What is the difference between the Balance of Payment (as % of service exports) of Bahamas in 2009 and the Balance of Payment (as % of service exports) of China in 2010?
Ensure brevity in your answer.  -16.58. What is the difference between the Balance of Payment (as % of service exports) of Bahamas in 2009 and the Balance of Payment (as % of service exports) of Sudan in 2010?
Keep it short and to the point. 1.43. What is the difference between the Balance of Payment (as % of service exports) in Bulgaria in 2009 and the Balance of Payment (as % of service exports) in China in 2010?
Give a very brief answer. 0.8. What is the difference between the Balance of Payment (as % of service exports) in Bulgaria in 2009 and the Balance of Payment (as % of service exports) in Sudan in 2010?
Offer a very short reply. 18.81. What is the difference between the Balance of Payment (as % of service exports) of China in 2009 and the Balance of Payment (as % of service exports) of Sudan in 2010?
Offer a very short reply. 14.4. What is the difference between the Balance of Payment (as % of service exports) in Bahamas in 2009 and the Balance of Payment (as % of service exports) in Bulgaria in 2011?
Give a very brief answer. -17.58. What is the difference between the Balance of Payment (as % of service exports) in Bahamas in 2009 and the Balance of Payment (as % of service exports) in China in 2011?
Make the answer very short. -15.88. What is the difference between the Balance of Payment (as % of service exports) of Bahamas in 2009 and the Balance of Payment (as % of service exports) of Sudan in 2011?
Provide a succinct answer. 0.97. What is the difference between the Balance of Payment (as % of service exports) of Bulgaria in 2009 and the Balance of Payment (as % of service exports) of China in 2011?
Ensure brevity in your answer.  1.5. What is the difference between the Balance of Payment (as % of service exports) of Bulgaria in 2009 and the Balance of Payment (as % of service exports) of Sudan in 2011?
Offer a very short reply. 18.35. What is the difference between the Balance of Payment (as % of service exports) in China in 2009 and the Balance of Payment (as % of service exports) in Sudan in 2011?
Offer a very short reply. 13.95. What is the difference between the Balance of Payment (as % of service exports) in Bahamas in 2009 and the Balance of Payment (as % of service exports) in Bulgaria in 2012?
Keep it short and to the point. -16.11. What is the difference between the Balance of Payment (as % of service exports) in Bahamas in 2009 and the Balance of Payment (as % of service exports) in China in 2012?
Provide a succinct answer. -14.63. What is the difference between the Balance of Payment (as % of service exports) of Bahamas in 2009 and the Balance of Payment (as % of service exports) of Sudan in 2012?
Provide a succinct answer. 2.03. What is the difference between the Balance of Payment (as % of service exports) of Bulgaria in 2009 and the Balance of Payment (as % of service exports) of China in 2012?
Provide a succinct answer. 2.75. What is the difference between the Balance of Payment (as % of service exports) in Bulgaria in 2009 and the Balance of Payment (as % of service exports) in Sudan in 2012?
Give a very brief answer. 19.41. What is the difference between the Balance of Payment (as % of service exports) of China in 2009 and the Balance of Payment (as % of service exports) of Sudan in 2012?
Offer a terse response. 15.01. What is the difference between the Balance of Payment (as % of service exports) of Bahamas in 2010 and the Balance of Payment (as % of service exports) of Bulgaria in 2011?
Offer a very short reply. -16.21. What is the difference between the Balance of Payment (as % of service exports) in Bahamas in 2010 and the Balance of Payment (as % of service exports) in China in 2011?
Your response must be concise. -14.51. What is the difference between the Balance of Payment (as % of service exports) in Bahamas in 2010 and the Balance of Payment (as % of service exports) in Sudan in 2011?
Offer a very short reply. 2.34. What is the difference between the Balance of Payment (as % of service exports) in Bulgaria in 2010 and the Balance of Payment (as % of service exports) in China in 2011?
Offer a very short reply. 0.7. What is the difference between the Balance of Payment (as % of service exports) of Bulgaria in 2010 and the Balance of Payment (as % of service exports) of Sudan in 2011?
Your response must be concise. 17.55. What is the difference between the Balance of Payment (as % of service exports) in China in 2010 and the Balance of Payment (as % of service exports) in Sudan in 2011?
Your answer should be compact. 17.55. What is the difference between the Balance of Payment (as % of service exports) of Bahamas in 2010 and the Balance of Payment (as % of service exports) of Bulgaria in 2012?
Offer a terse response. -14.74. What is the difference between the Balance of Payment (as % of service exports) of Bahamas in 2010 and the Balance of Payment (as % of service exports) of China in 2012?
Your answer should be compact. -13.26. What is the difference between the Balance of Payment (as % of service exports) of Bahamas in 2010 and the Balance of Payment (as % of service exports) of Sudan in 2012?
Make the answer very short. 3.4. What is the difference between the Balance of Payment (as % of service exports) in Bulgaria in 2010 and the Balance of Payment (as % of service exports) in China in 2012?
Offer a very short reply. 1.95. What is the difference between the Balance of Payment (as % of service exports) in Bulgaria in 2010 and the Balance of Payment (as % of service exports) in Sudan in 2012?
Offer a terse response. 18.61. What is the difference between the Balance of Payment (as % of service exports) in China in 2010 and the Balance of Payment (as % of service exports) in Sudan in 2012?
Provide a short and direct response. 18.61. What is the difference between the Balance of Payment (as % of service exports) of Bahamas in 2011 and the Balance of Payment (as % of service exports) of Bulgaria in 2012?
Make the answer very short. -14.21. What is the difference between the Balance of Payment (as % of service exports) in Bahamas in 2011 and the Balance of Payment (as % of service exports) in China in 2012?
Offer a terse response. -12.73. What is the difference between the Balance of Payment (as % of service exports) in Bahamas in 2011 and the Balance of Payment (as % of service exports) in Sudan in 2012?
Keep it short and to the point. 3.94. What is the difference between the Balance of Payment (as % of service exports) in Bulgaria in 2011 and the Balance of Payment (as % of service exports) in China in 2012?
Your response must be concise. 2.95. What is the difference between the Balance of Payment (as % of service exports) of Bulgaria in 2011 and the Balance of Payment (as % of service exports) of Sudan in 2012?
Ensure brevity in your answer.  19.61. What is the difference between the Balance of Payment (as % of service exports) in China in 2011 and the Balance of Payment (as % of service exports) in Sudan in 2012?
Keep it short and to the point. 17.91. What is the average Balance of Payment (as % of service exports) in Bahamas per year?
Give a very brief answer. 3.36. What is the average Balance of Payment (as % of service exports) in Bulgaria per year?
Give a very brief answer. 23.17. What is the average Balance of Payment (as % of service exports) in China per year?
Your answer should be very brief. 19.21. What is the average Balance of Payment (as % of service exports) of Sudan per year?
Ensure brevity in your answer.  2.91. In the year 2005, what is the difference between the Balance of Payment (as % of service exports) in Bahamas and Balance of Payment (as % of service exports) in Bulgaria?
Your answer should be compact. -25.25. In the year 2005, what is the difference between the Balance of Payment (as % of service exports) of Bahamas and Balance of Payment (as % of service exports) of China?
Your answer should be compact. -15.09. In the year 2005, what is the difference between the Balance of Payment (as % of service exports) of Bahamas and Balance of Payment (as % of service exports) of Sudan?
Keep it short and to the point. 0.11. In the year 2005, what is the difference between the Balance of Payment (as % of service exports) of Bulgaria and Balance of Payment (as % of service exports) of China?
Your answer should be compact. 10.16. In the year 2005, what is the difference between the Balance of Payment (as % of service exports) of Bulgaria and Balance of Payment (as % of service exports) of Sudan?
Keep it short and to the point. 25.36. In the year 2005, what is the difference between the Balance of Payment (as % of service exports) in China and Balance of Payment (as % of service exports) in Sudan?
Ensure brevity in your answer.  15.2. In the year 2006, what is the difference between the Balance of Payment (as % of service exports) of Bahamas and Balance of Payment (as % of service exports) of Bulgaria?
Offer a very short reply. -28.12. In the year 2006, what is the difference between the Balance of Payment (as % of service exports) in Bahamas and Balance of Payment (as % of service exports) in China?
Make the answer very short. -16.1. In the year 2006, what is the difference between the Balance of Payment (as % of service exports) of Bahamas and Balance of Payment (as % of service exports) of Sudan?
Give a very brief answer. -4.48. In the year 2006, what is the difference between the Balance of Payment (as % of service exports) in Bulgaria and Balance of Payment (as % of service exports) in China?
Give a very brief answer. 12.01. In the year 2006, what is the difference between the Balance of Payment (as % of service exports) in Bulgaria and Balance of Payment (as % of service exports) in Sudan?
Make the answer very short. 23.63. In the year 2006, what is the difference between the Balance of Payment (as % of service exports) in China and Balance of Payment (as % of service exports) in Sudan?
Provide a short and direct response. 11.62. In the year 2007, what is the difference between the Balance of Payment (as % of service exports) of Bahamas and Balance of Payment (as % of service exports) of Bulgaria?
Ensure brevity in your answer.  -21.39. In the year 2007, what is the difference between the Balance of Payment (as % of service exports) of Bahamas and Balance of Payment (as % of service exports) of China?
Keep it short and to the point. -19.02. In the year 2007, what is the difference between the Balance of Payment (as % of service exports) of Bahamas and Balance of Payment (as % of service exports) of Sudan?
Your answer should be very brief. 0.16. In the year 2007, what is the difference between the Balance of Payment (as % of service exports) of Bulgaria and Balance of Payment (as % of service exports) of China?
Provide a short and direct response. 2.36. In the year 2007, what is the difference between the Balance of Payment (as % of service exports) of Bulgaria and Balance of Payment (as % of service exports) of Sudan?
Provide a short and direct response. 21.55. In the year 2007, what is the difference between the Balance of Payment (as % of service exports) of China and Balance of Payment (as % of service exports) of Sudan?
Your response must be concise. 19.18. In the year 2008, what is the difference between the Balance of Payment (as % of service exports) of Bahamas and Balance of Payment (as % of service exports) of Bulgaria?
Provide a succinct answer. -20.63. In the year 2008, what is the difference between the Balance of Payment (as % of service exports) in Bahamas and Balance of Payment (as % of service exports) in China?
Provide a succinct answer. -21.06. In the year 2008, what is the difference between the Balance of Payment (as % of service exports) of Bahamas and Balance of Payment (as % of service exports) of Sudan?
Your answer should be very brief. -2.09. In the year 2008, what is the difference between the Balance of Payment (as % of service exports) of Bulgaria and Balance of Payment (as % of service exports) of China?
Make the answer very short. -0.44. In the year 2008, what is the difference between the Balance of Payment (as % of service exports) in Bulgaria and Balance of Payment (as % of service exports) in Sudan?
Make the answer very short. 18.54. In the year 2008, what is the difference between the Balance of Payment (as % of service exports) in China and Balance of Payment (as % of service exports) in Sudan?
Your answer should be very brief. 18.97. In the year 2009, what is the difference between the Balance of Payment (as % of service exports) of Bahamas and Balance of Payment (as % of service exports) of Bulgaria?
Your answer should be compact. -17.38. In the year 2009, what is the difference between the Balance of Payment (as % of service exports) of Bahamas and Balance of Payment (as % of service exports) of China?
Make the answer very short. -12.98. In the year 2009, what is the difference between the Balance of Payment (as % of service exports) of Bahamas and Balance of Payment (as % of service exports) of Sudan?
Provide a succinct answer. 0.96. In the year 2009, what is the difference between the Balance of Payment (as % of service exports) of Bulgaria and Balance of Payment (as % of service exports) of China?
Ensure brevity in your answer.  4.41. In the year 2009, what is the difference between the Balance of Payment (as % of service exports) of Bulgaria and Balance of Payment (as % of service exports) of Sudan?
Ensure brevity in your answer.  18.34. In the year 2009, what is the difference between the Balance of Payment (as % of service exports) in China and Balance of Payment (as % of service exports) in Sudan?
Provide a succinct answer. 13.93. In the year 2010, what is the difference between the Balance of Payment (as % of service exports) of Bahamas and Balance of Payment (as % of service exports) of Bulgaria?
Your answer should be very brief. -15.21. In the year 2010, what is the difference between the Balance of Payment (as % of service exports) in Bahamas and Balance of Payment (as % of service exports) in China?
Keep it short and to the point. -15.21. In the year 2010, what is the difference between the Balance of Payment (as % of service exports) in Bahamas and Balance of Payment (as % of service exports) in Sudan?
Your response must be concise. 2.8. In the year 2010, what is the difference between the Balance of Payment (as % of service exports) in Bulgaria and Balance of Payment (as % of service exports) in China?
Offer a terse response. 0. In the year 2010, what is the difference between the Balance of Payment (as % of service exports) in Bulgaria and Balance of Payment (as % of service exports) in Sudan?
Offer a terse response. 18.01. In the year 2010, what is the difference between the Balance of Payment (as % of service exports) of China and Balance of Payment (as % of service exports) of Sudan?
Your response must be concise. 18.01. In the year 2011, what is the difference between the Balance of Payment (as % of service exports) in Bahamas and Balance of Payment (as % of service exports) in Bulgaria?
Offer a terse response. -15.68. In the year 2011, what is the difference between the Balance of Payment (as % of service exports) of Bahamas and Balance of Payment (as % of service exports) of China?
Your answer should be very brief. -13.98. In the year 2011, what is the difference between the Balance of Payment (as % of service exports) in Bahamas and Balance of Payment (as % of service exports) in Sudan?
Provide a short and direct response. 2.88. In the year 2011, what is the difference between the Balance of Payment (as % of service exports) in Bulgaria and Balance of Payment (as % of service exports) in China?
Ensure brevity in your answer.  1.7. In the year 2011, what is the difference between the Balance of Payment (as % of service exports) of Bulgaria and Balance of Payment (as % of service exports) of Sudan?
Keep it short and to the point. 18.55. In the year 2011, what is the difference between the Balance of Payment (as % of service exports) of China and Balance of Payment (as % of service exports) of Sudan?
Provide a succinct answer. 16.85. In the year 2012, what is the difference between the Balance of Payment (as % of service exports) of Bahamas and Balance of Payment (as % of service exports) of Bulgaria?
Offer a terse response. -14.89. In the year 2012, what is the difference between the Balance of Payment (as % of service exports) in Bahamas and Balance of Payment (as % of service exports) in China?
Offer a very short reply. -13.41. In the year 2012, what is the difference between the Balance of Payment (as % of service exports) in Bahamas and Balance of Payment (as % of service exports) in Sudan?
Offer a very short reply. 3.26. In the year 2012, what is the difference between the Balance of Payment (as % of service exports) of Bulgaria and Balance of Payment (as % of service exports) of China?
Your answer should be very brief. 1.48. In the year 2012, what is the difference between the Balance of Payment (as % of service exports) of Bulgaria and Balance of Payment (as % of service exports) of Sudan?
Make the answer very short. 18.15. In the year 2012, what is the difference between the Balance of Payment (as % of service exports) in China and Balance of Payment (as % of service exports) in Sudan?
Offer a very short reply. 16.66. What is the ratio of the Balance of Payment (as % of service exports) of Bahamas in 2005 to that in 2006?
Provide a short and direct response. 0.94. What is the ratio of the Balance of Payment (as % of service exports) of Bulgaria in 2005 to that in 2006?
Your response must be concise. 0.9. What is the ratio of the Balance of Payment (as % of service exports) in Sudan in 2005 to that in 2006?
Offer a very short reply. 0.31. What is the ratio of the Balance of Payment (as % of service exports) in Bahamas in 2005 to that in 2007?
Offer a very short reply. 1. What is the ratio of the Balance of Payment (as % of service exports) in Bulgaria in 2005 to that in 2007?
Offer a very short reply. 1.16. What is the ratio of the Balance of Payment (as % of service exports) of China in 2005 to that in 2007?
Your answer should be very brief. 0.81. What is the ratio of the Balance of Payment (as % of service exports) of Sudan in 2005 to that in 2007?
Your answer should be compact. 1.03. What is the ratio of the Balance of Payment (as % of service exports) in Bahamas in 2005 to that in 2008?
Give a very brief answer. 1.06. What is the ratio of the Balance of Payment (as % of service exports) in Bulgaria in 2005 to that in 2008?
Offer a terse response. 1.21. What is the ratio of the Balance of Payment (as % of service exports) of China in 2005 to that in 2008?
Make the answer very short. 0.75. What is the ratio of the Balance of Payment (as % of service exports) in Sudan in 2005 to that in 2008?
Provide a succinct answer. 0.51. What is the ratio of the Balance of Payment (as % of service exports) of Bahamas in 2005 to that in 2009?
Keep it short and to the point. 0.66. What is the ratio of the Balance of Payment (as % of service exports) of Bulgaria in 2005 to that in 2009?
Your answer should be very brief. 1.32. What is the ratio of the Balance of Payment (as % of service exports) of China in 2005 to that in 2009?
Provide a short and direct response. 1.06. What is the ratio of the Balance of Payment (as % of service exports) in Sudan in 2005 to that in 2009?
Provide a short and direct response. 0.87. What is the ratio of the Balance of Payment (as % of service exports) in Bahamas in 2005 to that in 2010?
Your answer should be very brief. 0.47. What is the ratio of the Balance of Payment (as % of service exports) of Bulgaria in 2005 to that in 2010?
Make the answer very short. 1.38. What is the ratio of the Balance of Payment (as % of service exports) of China in 2005 to that in 2010?
Give a very brief answer. 0.87. What is the ratio of the Balance of Payment (as % of service exports) in Sudan in 2005 to that in 2010?
Ensure brevity in your answer.  1.08. What is the ratio of the Balance of Payment (as % of service exports) of Bahamas in 2005 to that in 2011?
Your answer should be compact. 0.42. What is the ratio of the Balance of Payment (as % of service exports) in Bulgaria in 2005 to that in 2011?
Ensure brevity in your answer.  1.31. What is the ratio of the Balance of Payment (as % of service exports) in China in 2005 to that in 2011?
Keep it short and to the point. 0.9. What is the ratio of the Balance of Payment (as % of service exports) in Sudan in 2005 to that in 2011?
Offer a terse response. 0.88. What is the ratio of the Balance of Payment (as % of service exports) of Bahamas in 2005 to that in 2012?
Provide a short and direct response. 0.48. What is the ratio of the Balance of Payment (as % of service exports) of Bulgaria in 2005 to that in 2012?
Your answer should be compact. 1.41. What is the ratio of the Balance of Payment (as % of service exports) of China in 2005 to that in 2012?
Your answer should be compact. 0.96. What is the ratio of the Balance of Payment (as % of service exports) of Sudan in 2005 to that in 2012?
Offer a terse response. 1.57. What is the ratio of the Balance of Payment (as % of service exports) of Bahamas in 2006 to that in 2007?
Offer a very short reply. 1.06. What is the ratio of the Balance of Payment (as % of service exports) of Bulgaria in 2006 to that in 2007?
Offer a very short reply. 1.29. What is the ratio of the Balance of Payment (as % of service exports) in China in 2006 to that in 2007?
Your answer should be compact. 0.87. What is the ratio of the Balance of Payment (as % of service exports) in Sudan in 2006 to that in 2007?
Keep it short and to the point. 3.33. What is the ratio of the Balance of Payment (as % of service exports) of Bahamas in 2006 to that in 2008?
Offer a terse response. 1.13. What is the ratio of the Balance of Payment (as % of service exports) in Bulgaria in 2006 to that in 2008?
Ensure brevity in your answer.  1.34. What is the ratio of the Balance of Payment (as % of service exports) of China in 2006 to that in 2008?
Your answer should be very brief. 0.8. What is the ratio of the Balance of Payment (as % of service exports) of Sudan in 2006 to that in 2008?
Offer a very short reply. 1.64. What is the ratio of the Balance of Payment (as % of service exports) of Bahamas in 2006 to that in 2009?
Ensure brevity in your answer.  0.7. What is the ratio of the Balance of Payment (as % of service exports) of Bulgaria in 2006 to that in 2009?
Offer a very short reply. 1.47. What is the ratio of the Balance of Payment (as % of service exports) of China in 2006 to that in 2009?
Your answer should be compact. 1.13. What is the ratio of the Balance of Payment (as % of service exports) of Sudan in 2006 to that in 2009?
Offer a terse response. 2.83. What is the ratio of the Balance of Payment (as % of service exports) of Bahamas in 2006 to that in 2010?
Your answer should be very brief. 0.5. What is the ratio of the Balance of Payment (as % of service exports) of Bulgaria in 2006 to that in 2010?
Give a very brief answer. 1.53. What is the ratio of the Balance of Payment (as % of service exports) in China in 2006 to that in 2010?
Your answer should be compact. 0.93. What is the ratio of the Balance of Payment (as % of service exports) of Sudan in 2006 to that in 2010?
Ensure brevity in your answer.  3.52. What is the ratio of the Balance of Payment (as % of service exports) in Bahamas in 2006 to that in 2011?
Your answer should be very brief. 0.45. What is the ratio of the Balance of Payment (as % of service exports) in Bulgaria in 2006 to that in 2011?
Your answer should be very brief. 1.45. What is the ratio of the Balance of Payment (as % of service exports) in China in 2006 to that in 2011?
Offer a terse response. 0.96. What is the ratio of the Balance of Payment (as % of service exports) of Sudan in 2006 to that in 2011?
Make the answer very short. 2.85. What is the ratio of the Balance of Payment (as % of service exports) in Bahamas in 2006 to that in 2012?
Ensure brevity in your answer.  0.51. What is the ratio of the Balance of Payment (as % of service exports) of Bulgaria in 2006 to that in 2012?
Give a very brief answer. 1.56. What is the ratio of the Balance of Payment (as % of service exports) in China in 2006 to that in 2012?
Your answer should be very brief. 1.03. What is the ratio of the Balance of Payment (as % of service exports) of Sudan in 2006 to that in 2012?
Provide a short and direct response. 5.11. What is the ratio of the Balance of Payment (as % of service exports) in Bahamas in 2007 to that in 2008?
Ensure brevity in your answer.  1.06. What is the ratio of the Balance of Payment (as % of service exports) in Bulgaria in 2007 to that in 2008?
Keep it short and to the point. 1.04. What is the ratio of the Balance of Payment (as % of service exports) in China in 2007 to that in 2008?
Keep it short and to the point. 0.92. What is the ratio of the Balance of Payment (as % of service exports) of Sudan in 2007 to that in 2008?
Offer a very short reply. 0.49. What is the ratio of the Balance of Payment (as % of service exports) of Bahamas in 2007 to that in 2009?
Provide a succinct answer. 0.66. What is the ratio of the Balance of Payment (as % of service exports) in Bulgaria in 2007 to that in 2009?
Make the answer very short. 1.14. What is the ratio of the Balance of Payment (as % of service exports) of China in 2007 to that in 2009?
Provide a short and direct response. 1.3. What is the ratio of the Balance of Payment (as % of service exports) in Sudan in 2007 to that in 2009?
Make the answer very short. 0.85. What is the ratio of the Balance of Payment (as % of service exports) in Bahamas in 2007 to that in 2010?
Keep it short and to the point. 0.47. What is the ratio of the Balance of Payment (as % of service exports) of Bulgaria in 2007 to that in 2010?
Keep it short and to the point. 1.18. What is the ratio of the Balance of Payment (as % of service exports) of China in 2007 to that in 2010?
Make the answer very short. 1.06. What is the ratio of the Balance of Payment (as % of service exports) of Sudan in 2007 to that in 2010?
Offer a very short reply. 1.06. What is the ratio of the Balance of Payment (as % of service exports) of Bahamas in 2007 to that in 2011?
Provide a succinct answer. 0.42. What is the ratio of the Balance of Payment (as % of service exports) in Bulgaria in 2007 to that in 2011?
Your answer should be compact. 1.13. What is the ratio of the Balance of Payment (as % of service exports) in China in 2007 to that in 2011?
Provide a short and direct response. 1.1. What is the ratio of the Balance of Payment (as % of service exports) of Sudan in 2007 to that in 2011?
Provide a succinct answer. 0.86. What is the ratio of the Balance of Payment (as % of service exports) in Bahamas in 2007 to that in 2012?
Offer a very short reply. 0.48. What is the ratio of the Balance of Payment (as % of service exports) of Bulgaria in 2007 to that in 2012?
Your answer should be very brief. 1.21. What is the ratio of the Balance of Payment (as % of service exports) in China in 2007 to that in 2012?
Make the answer very short. 1.18. What is the ratio of the Balance of Payment (as % of service exports) in Sudan in 2007 to that in 2012?
Offer a terse response. 1.53. What is the ratio of the Balance of Payment (as % of service exports) in Bahamas in 2008 to that in 2009?
Offer a terse response. 0.62. What is the ratio of the Balance of Payment (as % of service exports) of Bulgaria in 2008 to that in 2009?
Keep it short and to the point. 1.09. What is the ratio of the Balance of Payment (as % of service exports) of China in 2008 to that in 2009?
Offer a terse response. 1.42. What is the ratio of the Balance of Payment (as % of service exports) of Sudan in 2008 to that in 2009?
Make the answer very short. 1.73. What is the ratio of the Balance of Payment (as % of service exports) of Bahamas in 2008 to that in 2010?
Offer a terse response. 0.44. What is the ratio of the Balance of Payment (as % of service exports) in Bulgaria in 2008 to that in 2010?
Your answer should be very brief. 1.14. What is the ratio of the Balance of Payment (as % of service exports) of China in 2008 to that in 2010?
Provide a succinct answer. 1.16. What is the ratio of the Balance of Payment (as % of service exports) in Sudan in 2008 to that in 2010?
Your response must be concise. 2.15. What is the ratio of the Balance of Payment (as % of service exports) in Bahamas in 2008 to that in 2011?
Ensure brevity in your answer.  0.39. What is the ratio of the Balance of Payment (as % of service exports) in Bulgaria in 2008 to that in 2011?
Give a very brief answer. 1.08. What is the ratio of the Balance of Payment (as % of service exports) of China in 2008 to that in 2011?
Give a very brief answer. 1.2. What is the ratio of the Balance of Payment (as % of service exports) in Sudan in 2008 to that in 2011?
Your answer should be compact. 1.74. What is the ratio of the Balance of Payment (as % of service exports) of Bahamas in 2008 to that in 2012?
Make the answer very short. 0.45. What is the ratio of the Balance of Payment (as % of service exports) of Bulgaria in 2008 to that in 2012?
Give a very brief answer. 1.17. What is the ratio of the Balance of Payment (as % of service exports) in Sudan in 2008 to that in 2012?
Provide a succinct answer. 3.12. What is the ratio of the Balance of Payment (as % of service exports) of Bahamas in 2009 to that in 2010?
Provide a short and direct response. 0.71. What is the ratio of the Balance of Payment (as % of service exports) in Bulgaria in 2009 to that in 2010?
Provide a short and direct response. 1.04. What is the ratio of the Balance of Payment (as % of service exports) of China in 2009 to that in 2010?
Provide a short and direct response. 0.82. What is the ratio of the Balance of Payment (as % of service exports) in Sudan in 2009 to that in 2010?
Offer a very short reply. 1.24. What is the ratio of the Balance of Payment (as % of service exports) of Bahamas in 2009 to that in 2011?
Your response must be concise. 0.64. What is the ratio of the Balance of Payment (as % of service exports) of Bulgaria in 2009 to that in 2011?
Your answer should be compact. 0.99. What is the ratio of the Balance of Payment (as % of service exports) in China in 2009 to that in 2011?
Provide a succinct answer. 0.85. What is the ratio of the Balance of Payment (as % of service exports) in Sudan in 2009 to that in 2011?
Provide a short and direct response. 1.01. What is the ratio of the Balance of Payment (as % of service exports) of Bahamas in 2009 to that in 2012?
Offer a terse response. 0.73. What is the ratio of the Balance of Payment (as % of service exports) in Bulgaria in 2009 to that in 2012?
Your answer should be compact. 1.07. What is the ratio of the Balance of Payment (as % of service exports) in China in 2009 to that in 2012?
Your response must be concise. 0.91. What is the ratio of the Balance of Payment (as % of service exports) of Sudan in 2009 to that in 2012?
Ensure brevity in your answer.  1.8. What is the ratio of the Balance of Payment (as % of service exports) of Bahamas in 2010 to that in 2011?
Your response must be concise. 0.9. What is the ratio of the Balance of Payment (as % of service exports) of Bulgaria in 2010 to that in 2011?
Offer a terse response. 0.95. What is the ratio of the Balance of Payment (as % of service exports) in China in 2010 to that in 2011?
Your answer should be very brief. 1.04. What is the ratio of the Balance of Payment (as % of service exports) of Sudan in 2010 to that in 2011?
Provide a short and direct response. 0.81. What is the ratio of the Balance of Payment (as % of service exports) of Bahamas in 2010 to that in 2012?
Give a very brief answer. 1.03. What is the ratio of the Balance of Payment (as % of service exports) in China in 2010 to that in 2012?
Your answer should be very brief. 1.11. What is the ratio of the Balance of Payment (as % of service exports) in Sudan in 2010 to that in 2012?
Make the answer very short. 1.45. What is the ratio of the Balance of Payment (as % of service exports) of Bahamas in 2011 to that in 2012?
Keep it short and to the point. 1.15. What is the ratio of the Balance of Payment (as % of service exports) in Bulgaria in 2011 to that in 2012?
Your answer should be very brief. 1.08. What is the ratio of the Balance of Payment (as % of service exports) of China in 2011 to that in 2012?
Provide a short and direct response. 1.07. What is the ratio of the Balance of Payment (as % of service exports) of Sudan in 2011 to that in 2012?
Give a very brief answer. 1.79. What is the difference between the highest and the second highest Balance of Payment (as % of service exports) in Bahamas?
Your answer should be compact. 0.53. What is the difference between the highest and the second highest Balance of Payment (as % of service exports) of Bulgaria?
Ensure brevity in your answer.  3.01. What is the difference between the highest and the second highest Balance of Payment (as % of service exports) of China?
Ensure brevity in your answer.  1.91. What is the difference between the highest and the second highest Balance of Payment (as % of service exports) of Sudan?
Provide a short and direct response. 2.67. What is the difference between the highest and the lowest Balance of Payment (as % of service exports) of Bahamas?
Provide a short and direct response. 3.19. What is the difference between the highest and the lowest Balance of Payment (as % of service exports) of Bulgaria?
Make the answer very short. 10.99. What is the difference between the highest and the lowest Balance of Payment (as % of service exports) of China?
Give a very brief answer. 6.8. What is the difference between the highest and the lowest Balance of Payment (as % of service exports) in Sudan?
Give a very brief answer. 5.5. 